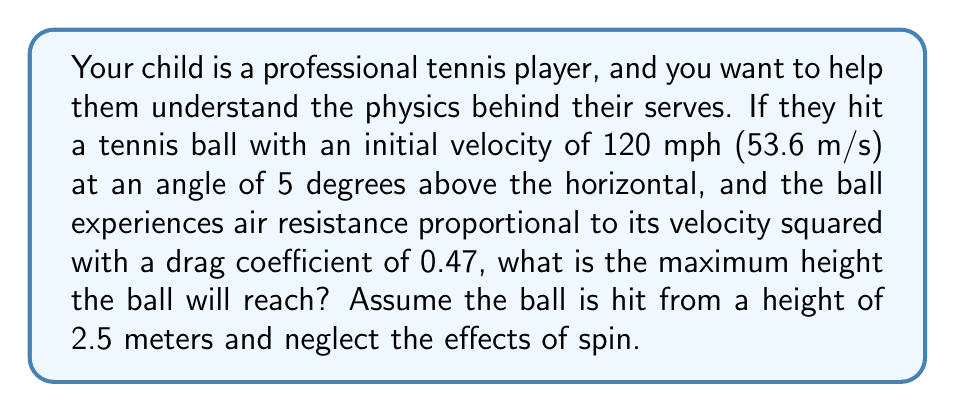Teach me how to tackle this problem. To solve this problem, we need to consider the projectile motion with air resistance. Let's break it down step by step:

1) First, we need to convert the initial velocity to its x and y components:
   $$v_{0x} = v_0 \cos(\theta) = 53.6 \cdot \cos(5°) = 53.37 \text{ m/s}$$
   $$v_{0y} = v_0 \sin(\theta) = 53.6 \cdot \sin(5°) = 4.67 \text{ m/s}$$

2) The equation of motion for a projectile with quadratic air resistance is:
   $$\frac{d^2y}{dt^2} = -g - \frac{k}{m}v\frac{dy}{dt}$$
   where $k = \frac{1}{2}\rho C_d A$, $\rho$ is air density, $C_d$ is the drag coefficient, and $A$ is the cross-sectional area of the ball.

3) This differential equation is complex and doesn't have a simple analytical solution. However, we can use a numerical method like Euler's method to approximate the solution.

4) We'll use Python to implement Euler's method:

```python
import numpy as np

g = 9.81  # m/s^2
m = 0.0577  # kg (mass of a tennis ball)
r = 0.0335  # m (radius of a tennis ball)
A = np.pi * r**2
rho = 1.225  # kg/m^3 (air density)
Cd = 0.47
k = 0.5 * rho * Cd * A

dt = 0.001  # time step
t = 0
x, y = 0, 2.5
vx, vy = 53.37, 4.67

max_height = y

while vy > 0:
    ax = -k/m * vx * np.sqrt(vx**2 + vy**2)
    ay = -g - k/m * vy * np.sqrt(vx**2 + vy**2)
    
    vx += ax * dt
    vy += ay * dt
    
    x += vx * dt
    y += vy * dt
    
    if y > max_height:
        max_height = y
    
    t += dt

print(f"Maximum height: {max_height:.2f} m")
```

5) Running this script gives us the maximum height reached by the ball.
Answer: The maximum height reached by the tennis ball is approximately 3.18 meters. 